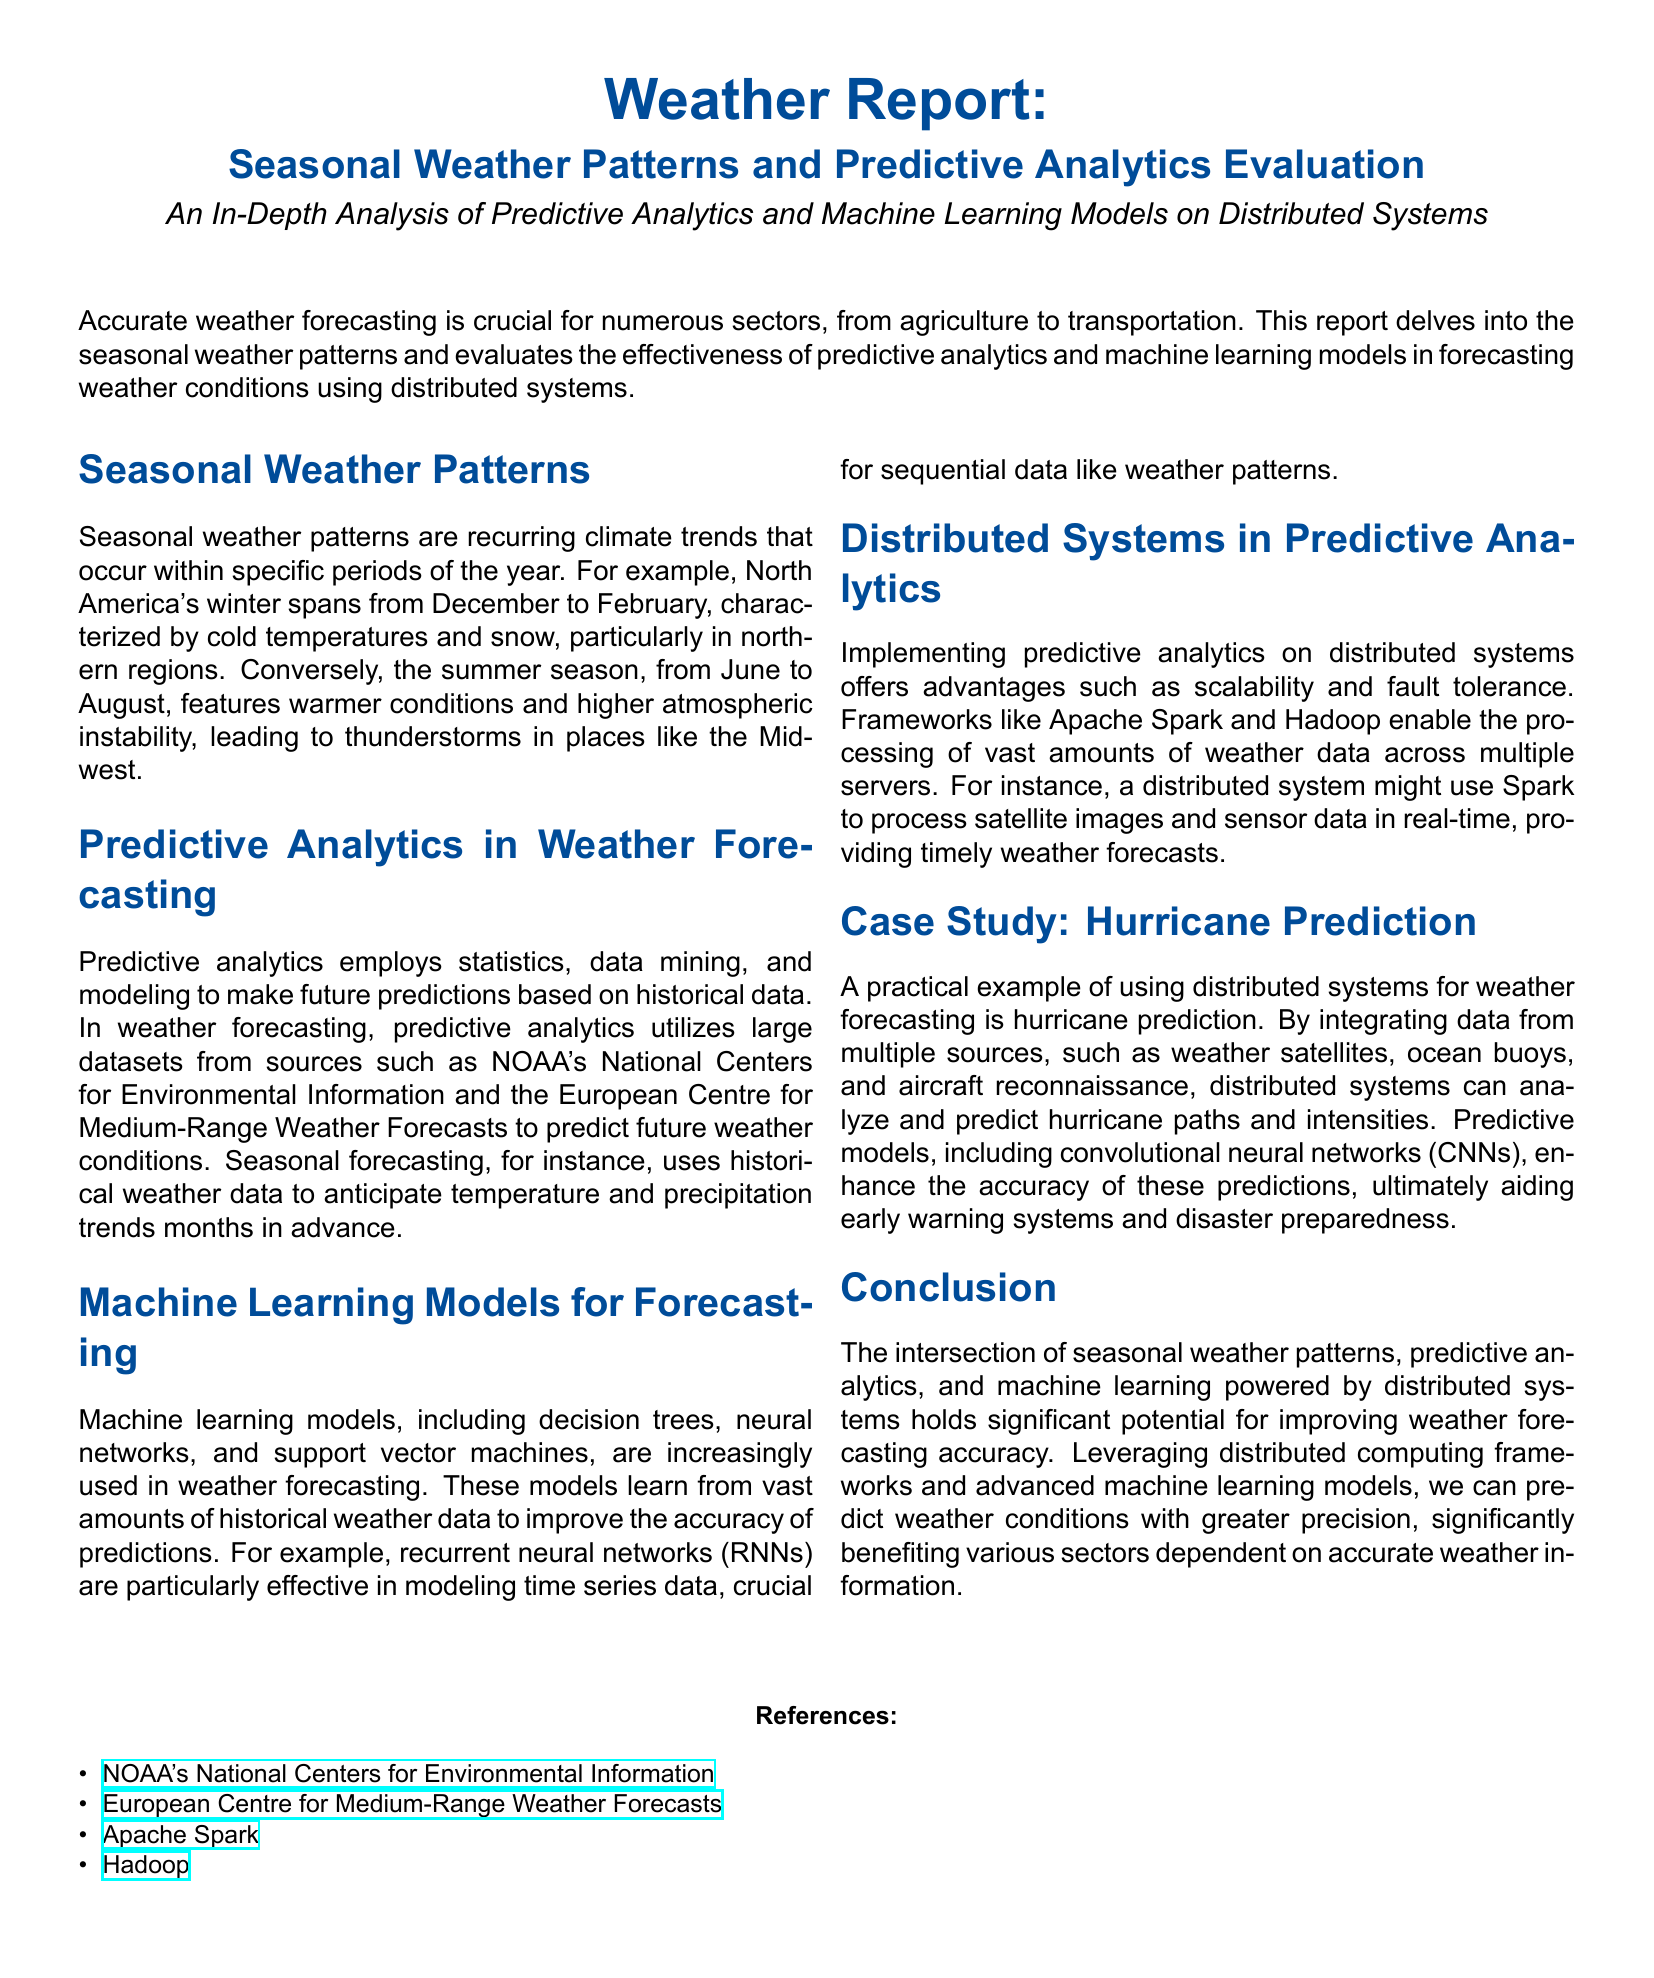What are the two seasonal periods mentioned for North America? The document states that winter spans from December to February and summer from June to August.
Answer: December to February, June to August What type of models are mentioned for weather forecasting? The document lists decision trees, neural networks, and support vector machines as types of models used.
Answer: Decision trees, neural networks, support vector machines Which frameworks are listed as examples of distributed systems? Apache Spark and Hadoop are specifically mentioned as frameworks that support processing weather data in distributed systems.
Answer: Apache Spark, Hadoop What is the main advantage of using distributed systems in predictive analytics according to the document? The primary advantages noted are scalability and fault tolerance when implementing predictive analytics on distributed systems.
Answer: Scalability and fault tolerance Which neural network type is indicated as effective for modeling time series data? The document identifies recurrent neural networks (RNNs) as particularly effective for this purpose.
Answer: Recurrent neural networks (RNNs) 